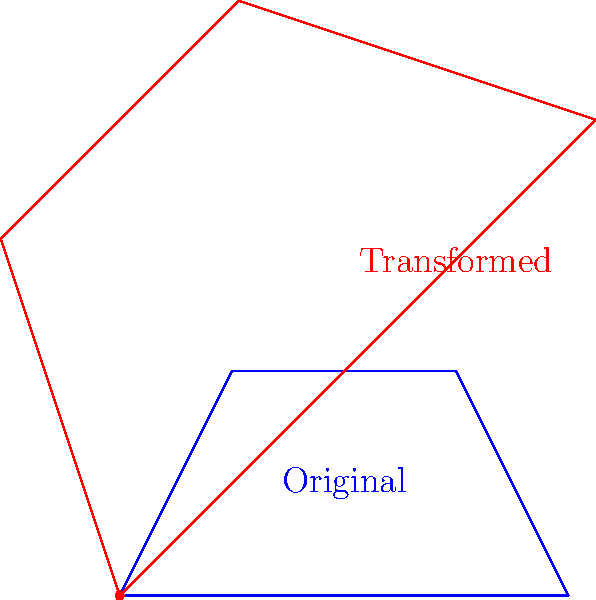A 2D representation of a preserved ancient fruit is rotated 45° counterclockwise around the origin and then scaled by a factor of 1.5. If the original fruit outline had a maximum width of 4 units, what is the maximum width of the transformed outline? To solve this problem, we need to follow these steps:

1. Understand the transformations:
   - Rotation by 45° counterclockwise
   - Scaling by a factor of 1.5

2. Consider the effect of rotation:
   - Rotation alone does not change the dimensions of the shape

3. Apply the scaling factor:
   - The scaling factor is 1.5
   - This means all dimensions will be multiplied by 1.5

4. Calculate the new maximum width:
   - Original maximum width = 4 units
   - New maximum width = 4 * 1.5 = 6 units

Therefore, the maximum width of the transformed outline is 6 units.
Answer: 6 units 